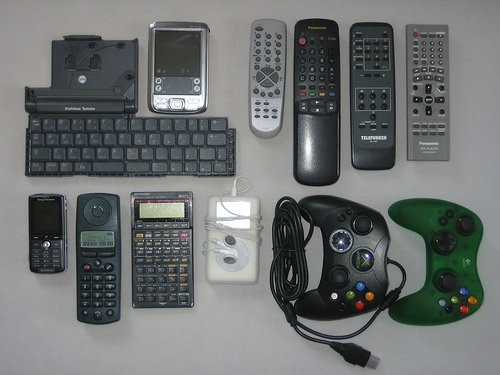Describe the objects in this image and their specific colors. I can see keyboard in gray, black, and purple tones, remote in gray, black, darkgreen, teal, and darkgray tones, remote in gray, black, and purple tones, remote in gray, black, darkgray, and purple tones, and remote in gray, black, and purple tones in this image. 